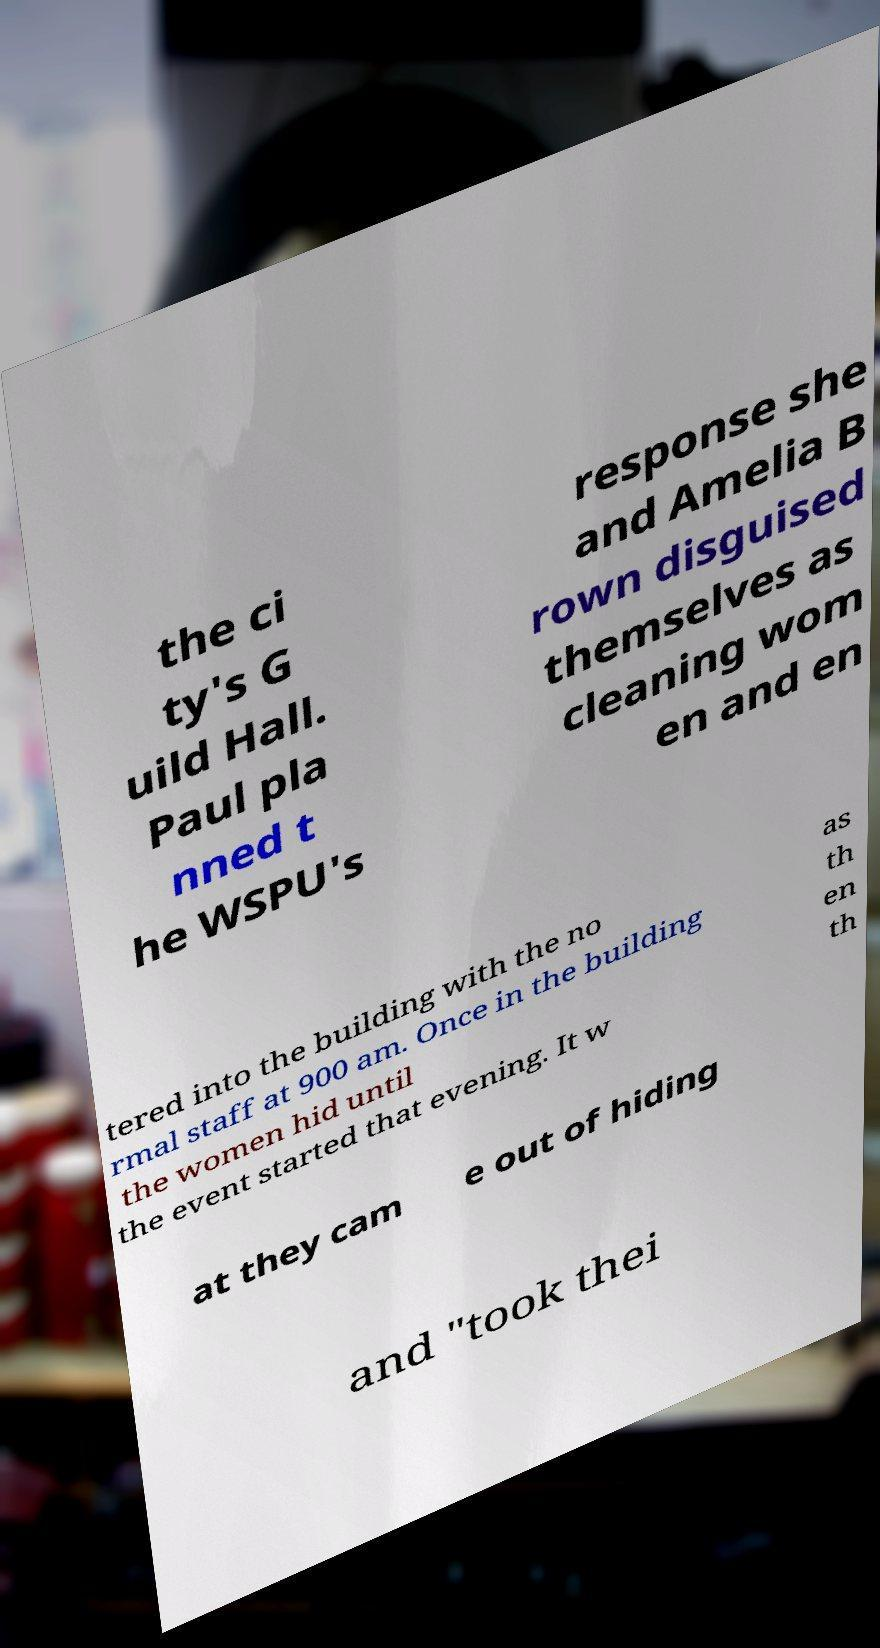Could you extract and type out the text from this image? the ci ty's G uild Hall. Paul pla nned t he WSPU's response she and Amelia B rown disguised themselves as cleaning wom en and en tered into the building with the no rmal staff at 900 am. Once in the building the women hid until the event started that evening. It w as th en th at they cam e out of hiding and "took thei 